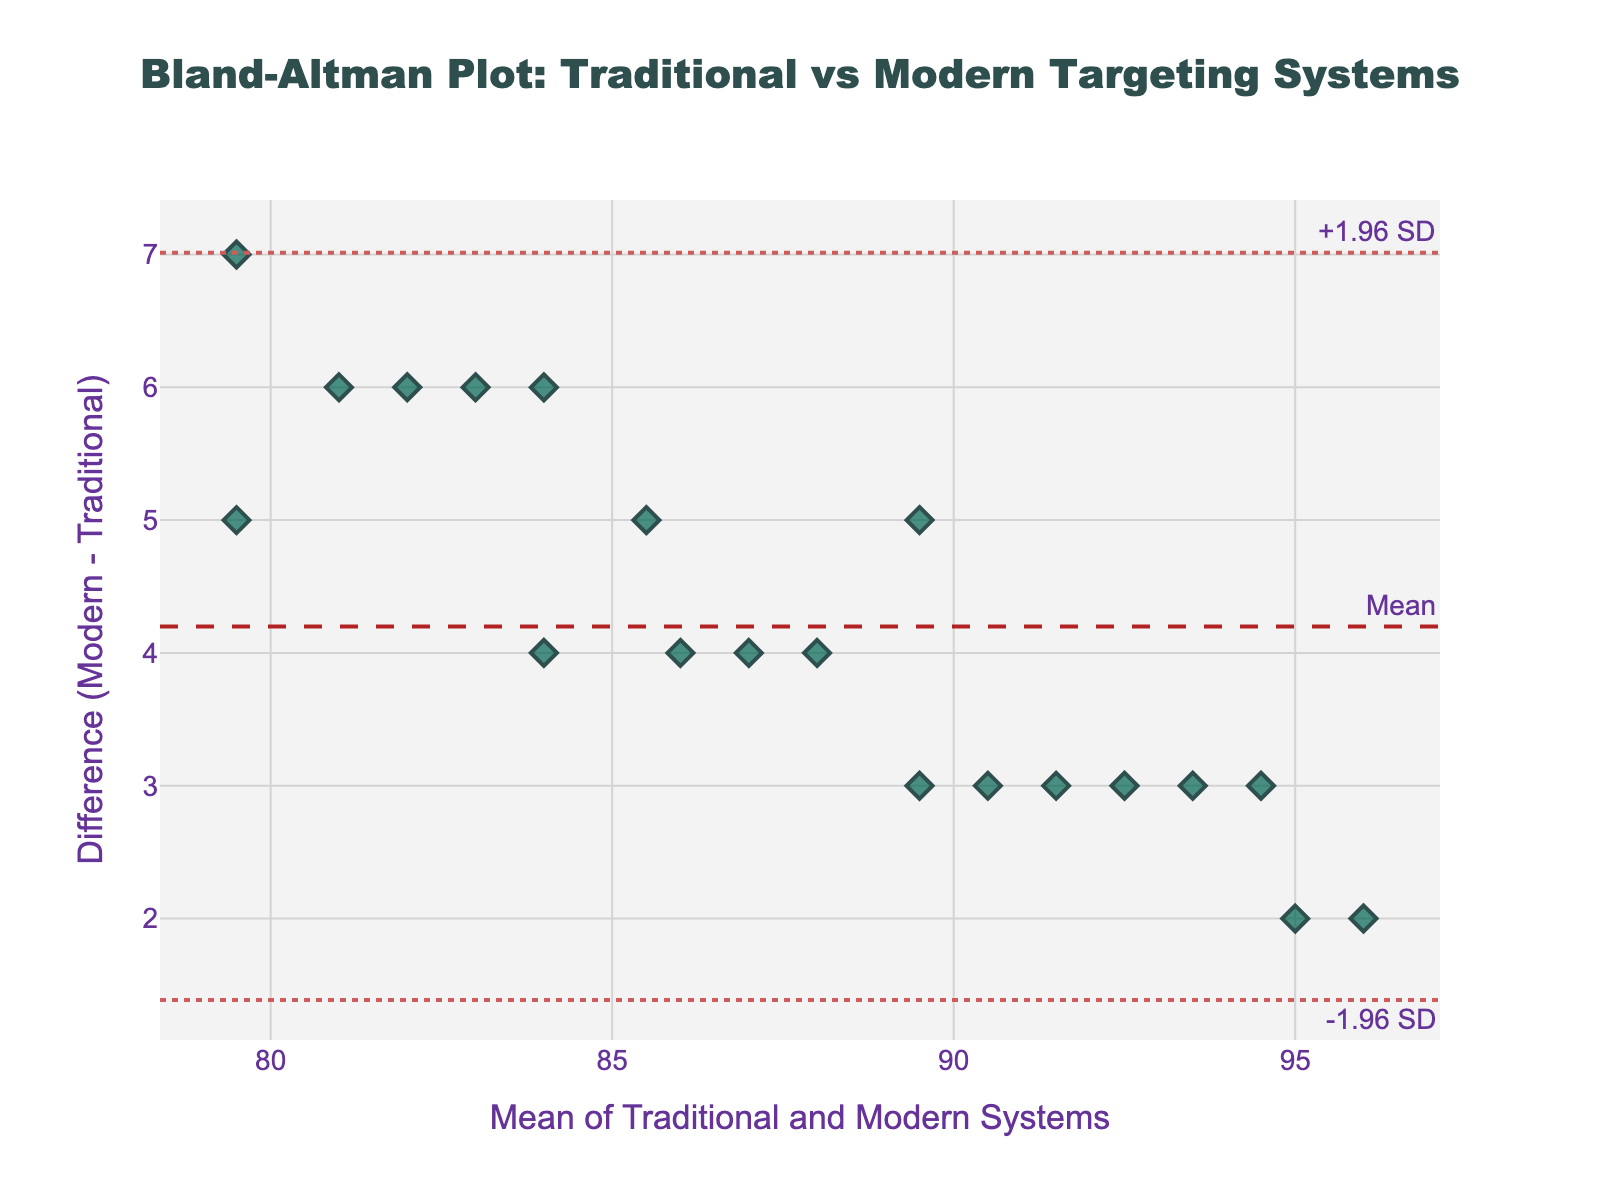What's the title of the figure? The title is located at the top center of the plot and is typically in larger font size.
Answer: Bland-Altman Plot: Traditional vs Modern Targeting Systems How many data points are there in the plot? Count the number of markers (diamond shapes) plotted on the graph.
Answer: 20 What do the x-axis and y-axis represent? The x-axis is labeled "Mean of Traditional and Modern Systems" and the y-axis is labeled "Difference (Modern - Traditional)," indicating what is measured along each axis.
Answer: The x-axis represents the mean scores of traditional and modern systems, and the y-axis represents the difference between the modern and traditional systems What's the mean difference between the modern and traditional systems? The mean difference is represented by a dashed horizontal line annotated as "Mean," indicating the average of the differences.
Answer: This value is approximately the horizontal position of the dashed line What are the upper and lower limits of agreement in the plot? These are represented by the dotted lines annotated as "+1.96 SD" and "-1.96 SD," respectively. These lines represent the mean difference plus or minus 1.96 times the standard deviation of the differences.
Answer: The values of these limits correspond to the horizontal positions of the dotted lines Are there any data points outside the limits of agreement? Look to see if any of the data points (diamond shapes) lie above the upper dotted line or below the lower dotted line.
Answer: No What colors are used for the markers and lines on the plot? The markers (data points) are colored green with a dark grey outline, while the lines use various shades of red: the mean line is firebrick (dark red), and the limit lines are Indian red.
Answer: Green for data points, dark red for the mean line, and red for limit lines Are the differences between the systems mostly positive or negative? Observe the distribution of the data points with respect to the zero line on the y-axis. If more points are above this line, differences are mostly positive; if below, they are negative.
Answer: Mostly positive How is the homogeneity of the differences across the range of means? Examine the spread of the data point differences across the range of the mean values on the x-axis. If the spread remains consistent, the differences are homogeneous; if not, they are heterogeneous.
Answer: They are relatively homogeneous What can you infer if many data points are close to the mean difference line? If data points cluster close to the mean difference line, it suggests that the differences between the traditional and modern systems are quite consistent.
Answer: The differences are consistent 